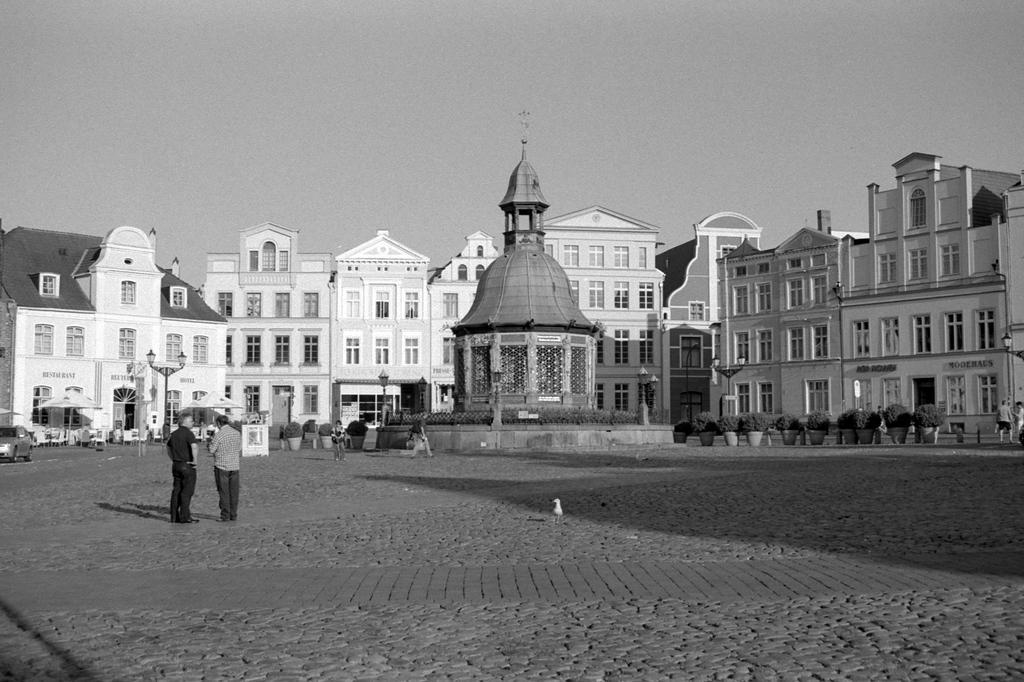Can you describe this image briefly? This image is taken outdoors. This image is a black and white image. At the top of the image there is the sky. At the bottom of the image there is a floor. In the background there are a few buildings with walls, windows, doors and rooms. There are a few poles with street lights and there are a few plants in the pots. There are a few empty chairs on the floor and there is a board. In the middle of the image there is an architecture and there are a few plants. Two men are standing on the floor. On the left side of the image a car is parked on the floor. On the right side of the image there are two persons and there are a few plants in the pots. 